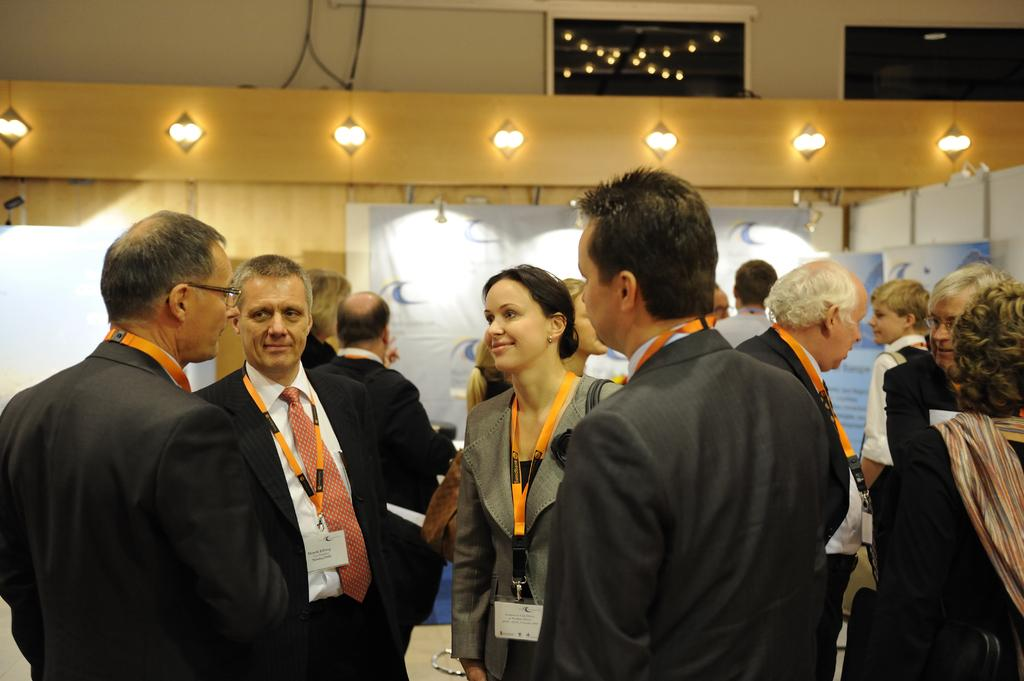How many people are present in the image? There are multiple persons in the image. Where was the image taken? The image was taken inside a room. What can be seen at the top of the image? There are lights at the top of the image. Can you describe the gender distribution of the people in the image? There are both men and women in the image. What type of circle can be seen in the image? There is no circle present in the image. 